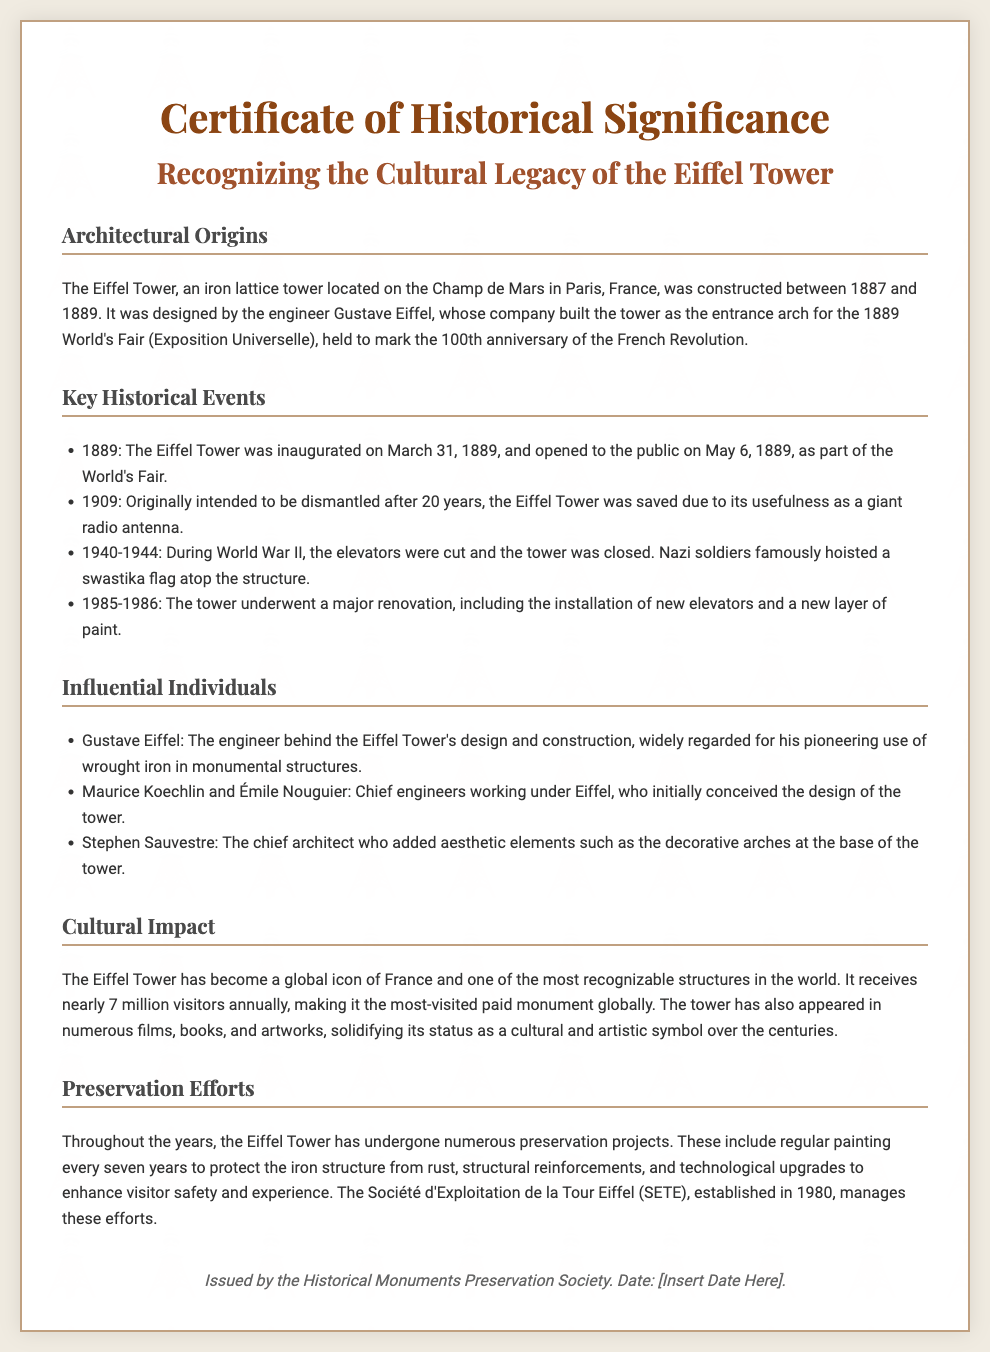What year was the Eiffel Tower constructed? The document states that the Eiffel Tower was constructed between 1887 and 1889.
Answer: 1889 Who designed the Eiffel Tower? According to the document, the Eiffel Tower was designed by the engineer Gustave Eiffel.
Answer: Gustave Eiffel What significant event did the Eiffel Tower inaugurate? The document mentions that the Eiffel Tower was inaugurated as part of the 1889 World's Fair.
Answer: 1889 World's Fair How many visitors does the Eiffel Tower receive annually? The document notes that the Eiffel Tower receives nearly 7 million visitors annually.
Answer: 7 million Which individual added aesthetic elements to the Eiffel Tower? The document lists Stephen Sauvestre as the chief architect who added aesthetic elements.
Answer: Stephen Sauvestre What was one reason the Eiffel Tower was not dismantled in 1909? The document explains that the Eiffel Tower was saved due to its usefulness as a giant radio antenna.
Answer: Giant radio antenna What organization manages preservation efforts for the Eiffel Tower? The document states that the Société d'Exploitation de la Tour Eiffel (SETE) manages preservation efforts.
Answer: SETE Why was the Eiffel Tower closed during 1940-1944? According to the document, the Eiffel Tower was closed during World War II because the elevators were cut.
Answer: The elevators were cut What is the color of the certificate's border? The document states that the certificate has a border in the color #c0a080.
Answer: #c0a080 